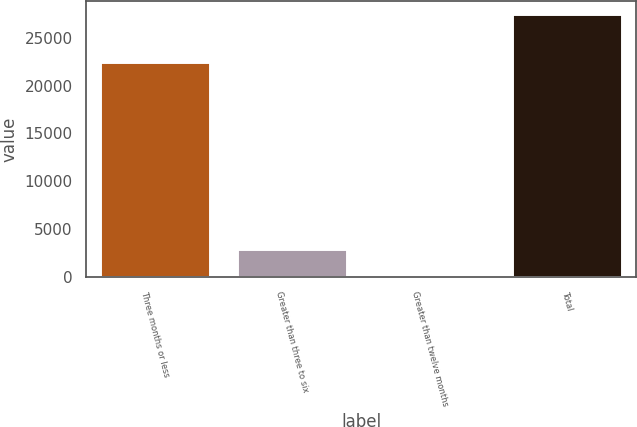Convert chart. <chart><loc_0><loc_0><loc_500><loc_500><bar_chart><fcel>Three months or less<fcel>Greater than three to six<fcel>Greater than twelve months<fcel>Total<nl><fcel>22449<fcel>2962.5<fcel>240<fcel>27465<nl></chart> 